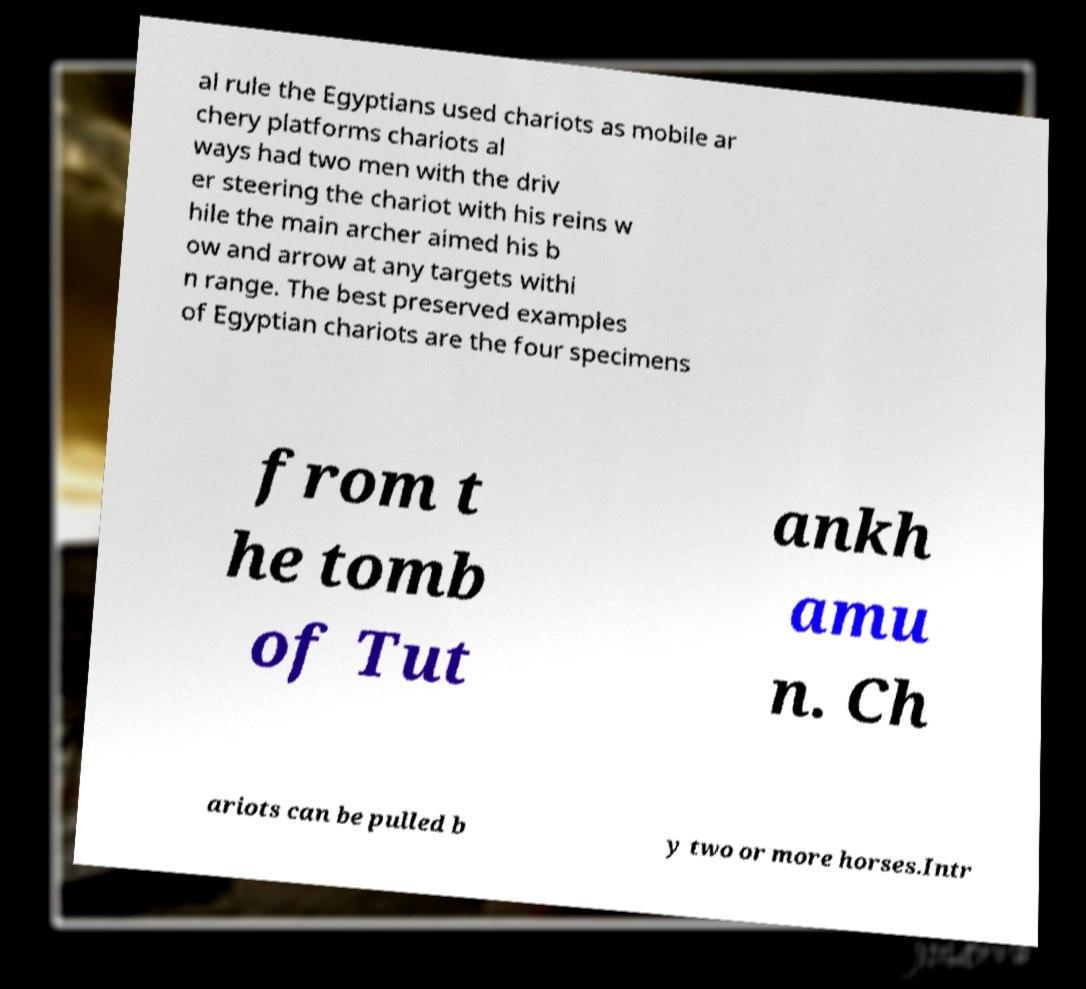Could you assist in decoding the text presented in this image and type it out clearly? al rule the Egyptians used chariots as mobile ar chery platforms chariots al ways had two men with the driv er steering the chariot with his reins w hile the main archer aimed his b ow and arrow at any targets withi n range. The best preserved examples of Egyptian chariots are the four specimens from t he tomb of Tut ankh amu n. Ch ariots can be pulled b y two or more horses.Intr 